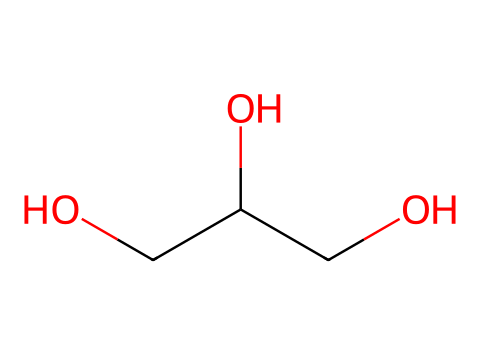What is the primary functional group in glycerin? The structure contains multiple hydroxyl (-OH) groups, indicating that glycerin has alcohol functional groups. The presence of these hydroxyl groups is critical for the properties of glycerin as a humectant and lubricant.
Answer: hydroxyl How many carbon atoms are present in glycerin? By examining the chemical structure, we can count three carbon atoms present in the backbone of glycerin. The carbon atoms are the central elements forming the main chain of the molecule.
Answer: three What is the total number of hydrogen atoms in glycerin? The structure has three carbon atoms and three hydroxyl groups. Each carbon can typically form four bonds, while the hydroxyl groups contribute extra hydrogen atoms. By adding the contributions, the total comes to eight hydrogen atoms.
Answer: eight What are the properties of glycerin that make it suitable as a lubricant? Glycerin is a viscous, hygroscopic substance due to its hydroxyl groups, allowing it to retain moisture while providing smoothness and consistency. These properties impart lubricating effects in oral medications.
Answer: viscous and hygroscopic What type of solvent can glycerin act as? Given its polar hydroxyl groups, glycerin is capable of dissolving both polar and non-polar substances to a degree, allowing it to serve as a good solvent in many formulations.
Answer: solvent How does the molecular structure of glycerin contribute to its use as a humectant? The presence of multiple hydroxyl groups in glycerin enables it to attract and retain water molecules from the environment, thus providing moisture. This feature is essential for its role as a humectant in medications.
Answer: attracts moisture In what type of formulations is glycerin commonly used as a lubricant? Glycerin is primarily used in oral medications, such as syrups and gels, due to its safety, efficacy, and ability to enhance the texture and flow properties of the formulation.
Answer: oral medications 